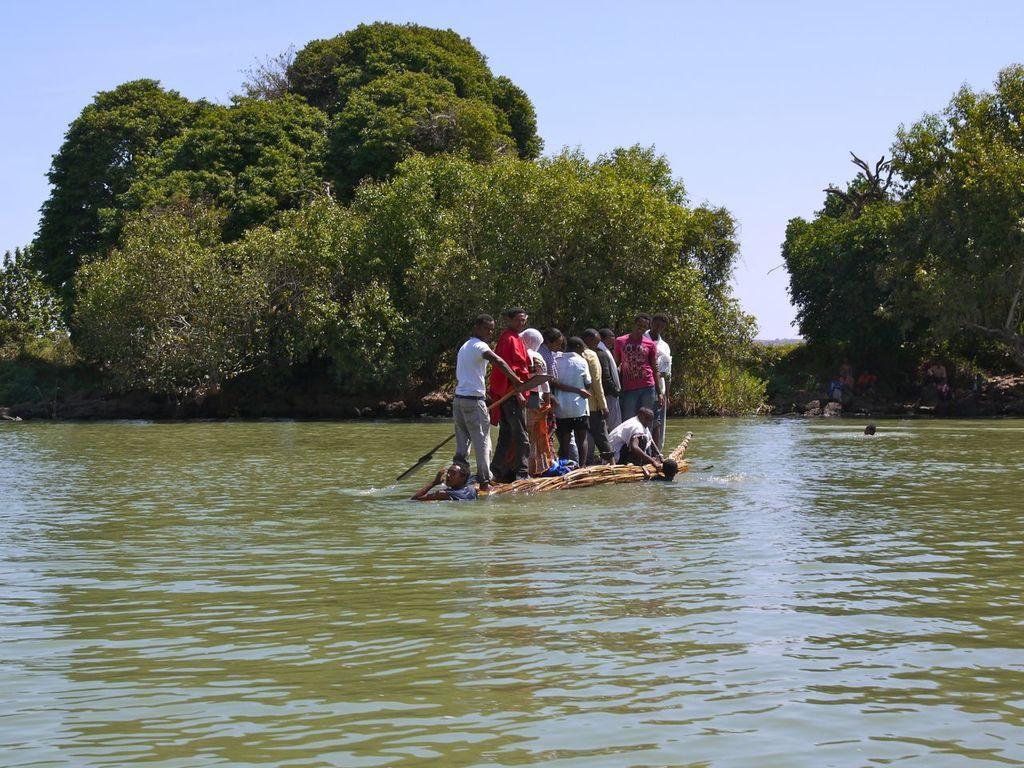Describe this image in one or two sentences. This picture is clicked on a river side. There are few people standing on a boat. There is a man holding paddle in his hand. There are few people in water too. In the background there are trees and sky. 